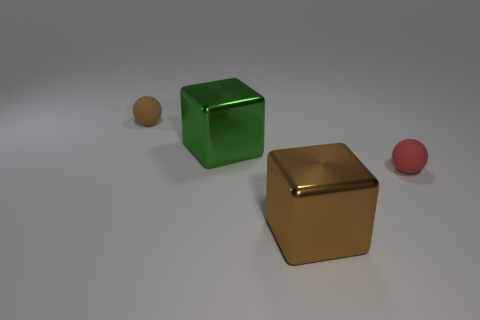Add 1 big gray rubber blocks. How many objects exist? 5 Add 3 brown blocks. How many brown blocks are left? 4 Add 1 small brown matte things. How many small brown matte things exist? 2 Subtract 1 brown blocks. How many objects are left? 3 Subtract all purple balls. Subtract all metallic blocks. How many objects are left? 2 